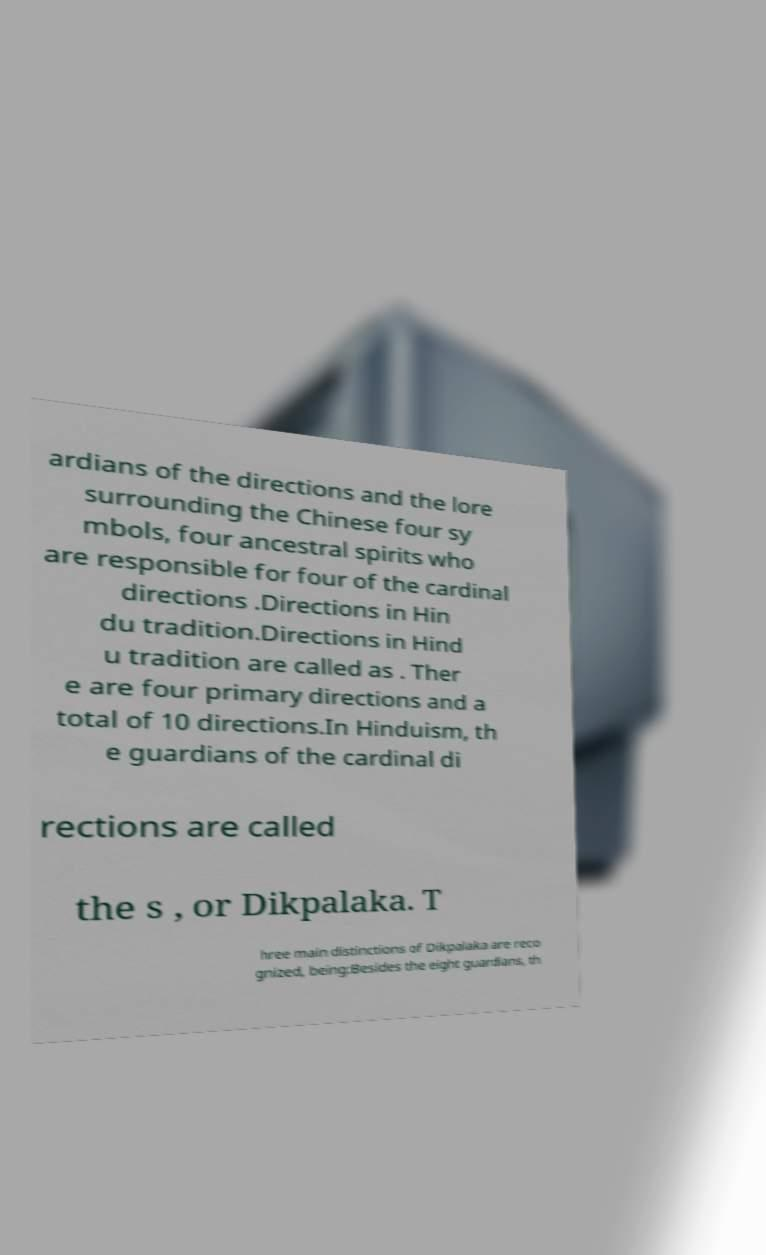Could you extract and type out the text from this image? ardians of the directions and the lore surrounding the Chinese four sy mbols, four ancestral spirits who are responsible for four of the cardinal directions .Directions in Hin du tradition.Directions in Hind u tradition are called as . Ther e are four primary directions and a total of 10 directions.In Hinduism, th e guardians of the cardinal di rections are called the s , or Dikpalaka. T hree main distinctions of Dikpalaka are reco gnized, being:Besides the eight guardians, th 